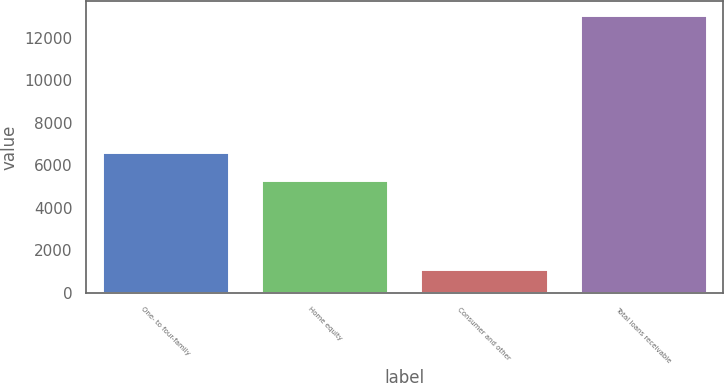Convert chart to OTSL. <chart><loc_0><loc_0><loc_500><loc_500><bar_chart><fcel>One- to four-family<fcel>Home equity<fcel>Consumer and other<fcel>Total loans receivable<nl><fcel>6615.8<fcel>5328.7<fcel>1113.2<fcel>13057.7<nl></chart> 